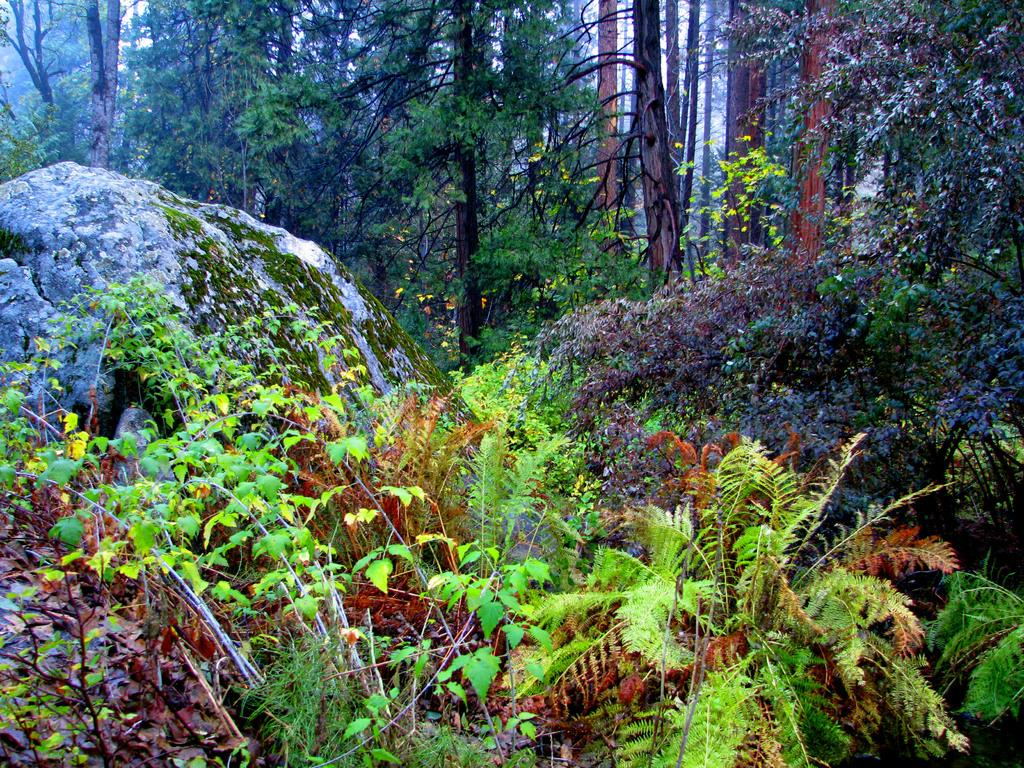What type of scenery is shown in the image? The image depicts a beautiful scenery. What can be observed in the image besides the scenery? There are many plants and trees in the image. Can you describe the rock in the image? There is a huge rock between the trees in the image. Where is the faucet located in the image? There is no faucet present in the image. What color is the tongue of the plant in the image? There is no tongue present in the image, as plants do not have tongues. 